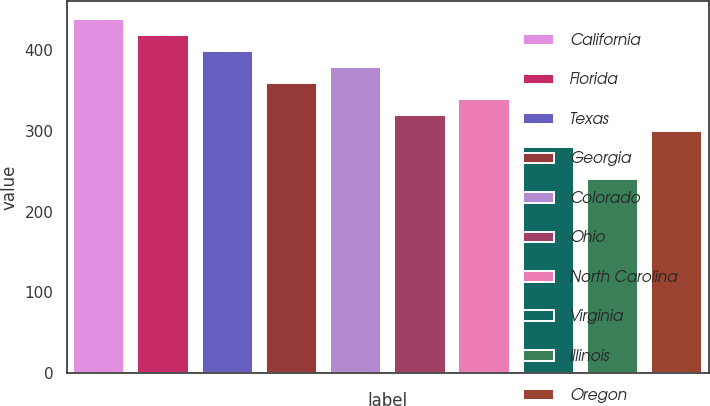Convert chart to OTSL. <chart><loc_0><loc_0><loc_500><loc_500><bar_chart><fcel>California<fcel>Florida<fcel>Texas<fcel>Georgia<fcel>Colorado<fcel>Ohio<fcel>North Carolina<fcel>Virginia<fcel>Illinois<fcel>Oregon<nl><fcel>438.8<fcel>418.9<fcel>399<fcel>359.2<fcel>379.1<fcel>319.4<fcel>339.3<fcel>279.6<fcel>239.8<fcel>299.5<nl></chart> 